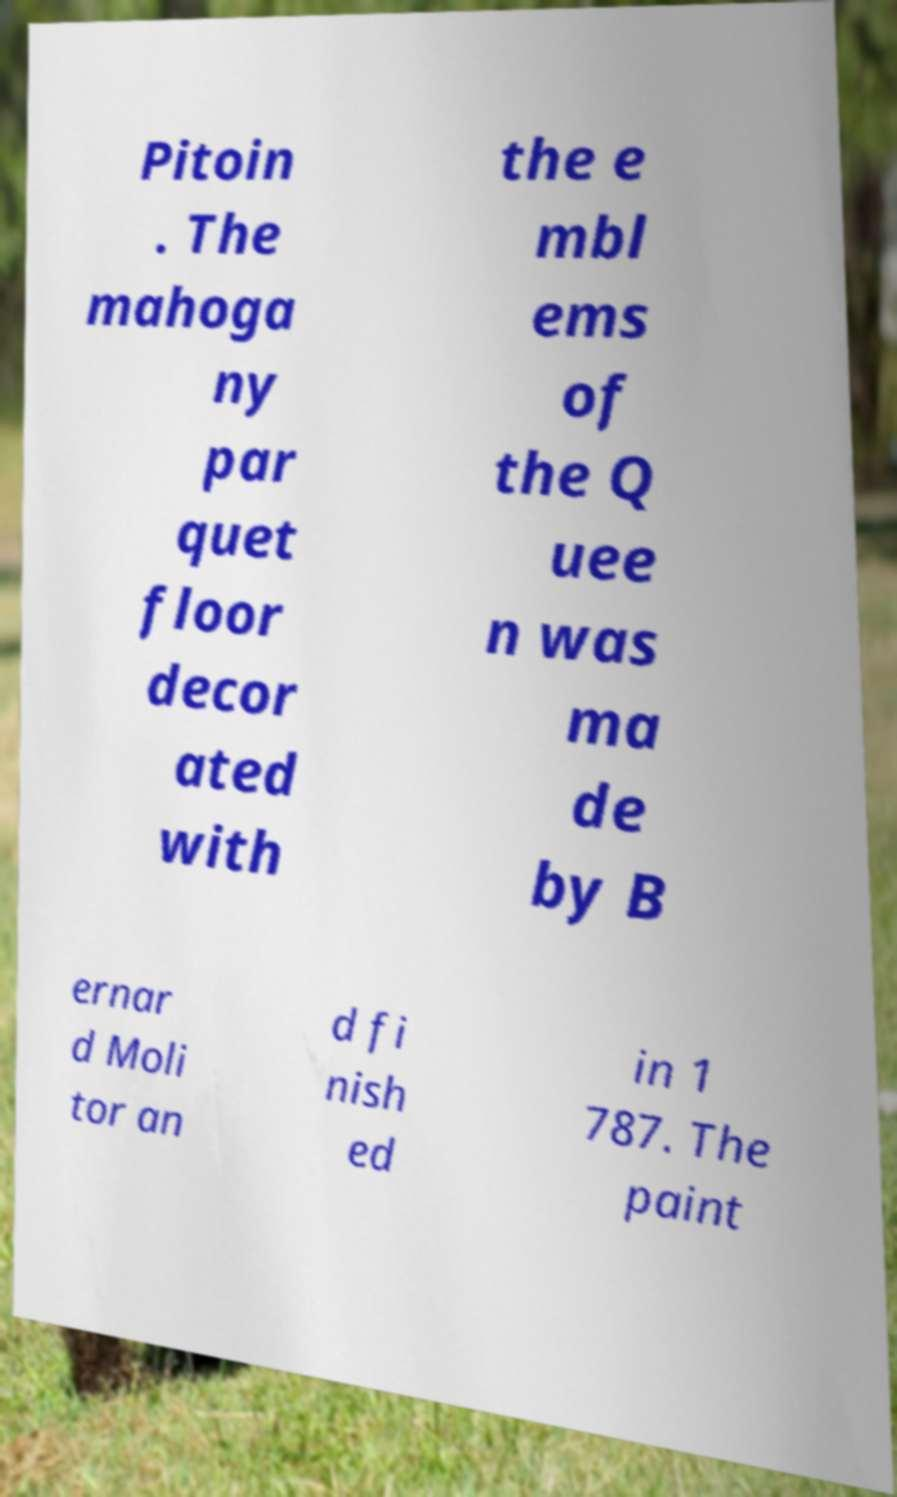What messages or text are displayed in this image? I need them in a readable, typed format. Pitoin . The mahoga ny par quet floor decor ated with the e mbl ems of the Q uee n was ma de by B ernar d Moli tor an d fi nish ed in 1 787. The paint 